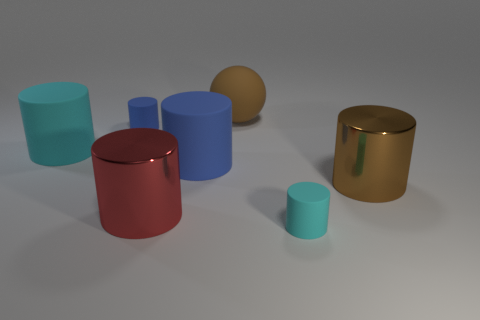Add 1 cyan matte cylinders. How many objects exist? 8 Subtract all large metallic cylinders. How many cylinders are left? 4 Subtract all brown spheres. How many blue cylinders are left? 2 Subtract 4 cylinders. How many cylinders are left? 2 Subtract all red cylinders. How many cylinders are left? 5 Subtract all cylinders. How many objects are left? 1 Add 6 brown things. How many brown things exist? 8 Subtract 0 yellow cylinders. How many objects are left? 7 Subtract all red cylinders. Subtract all brown balls. How many cylinders are left? 5 Subtract all big blue matte things. Subtract all shiny objects. How many objects are left? 4 